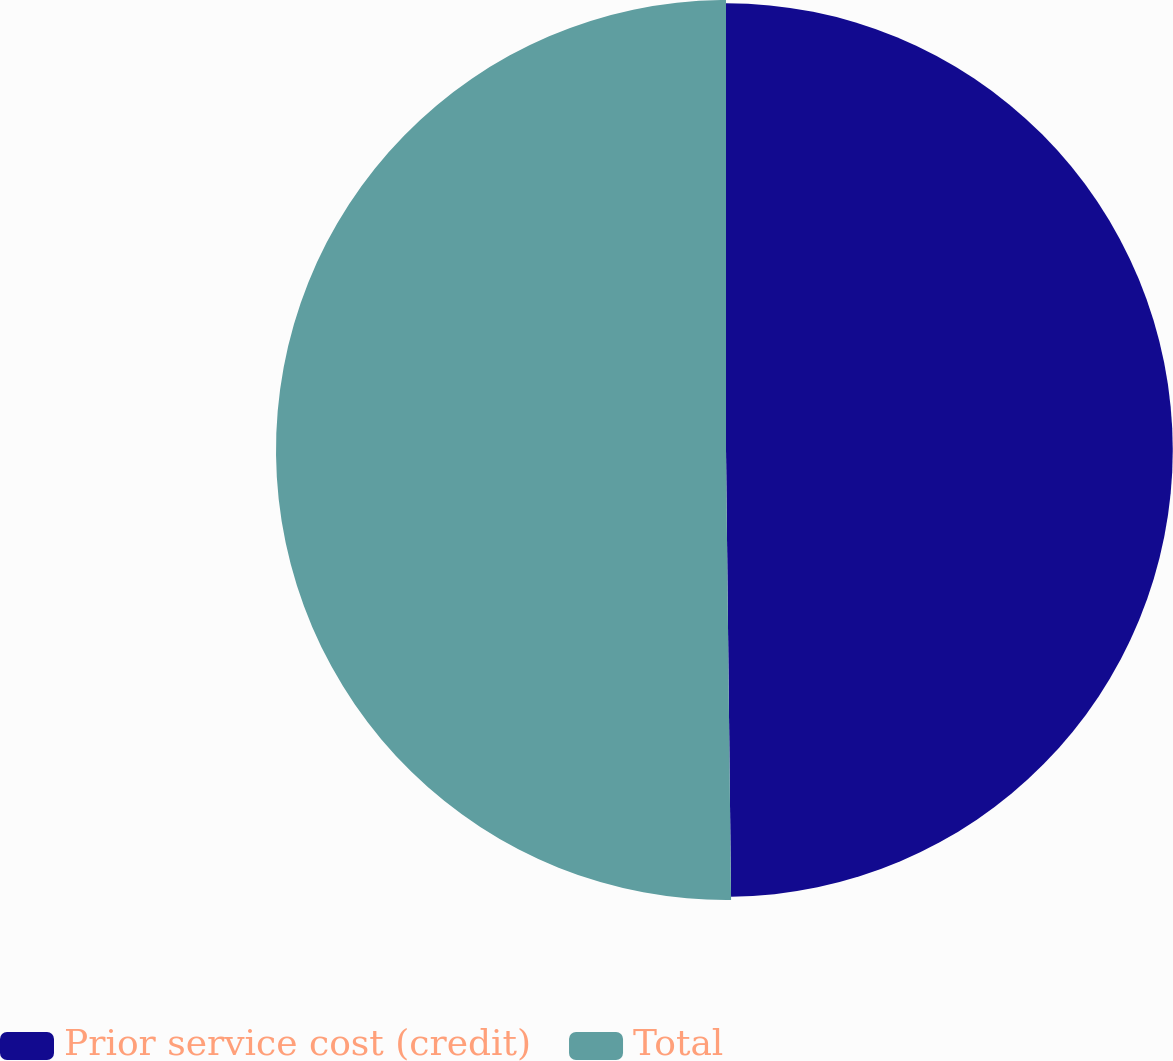Convert chart. <chart><loc_0><loc_0><loc_500><loc_500><pie_chart><fcel>Prior service cost (credit)<fcel>Total<nl><fcel>49.82%<fcel>50.18%<nl></chart> 